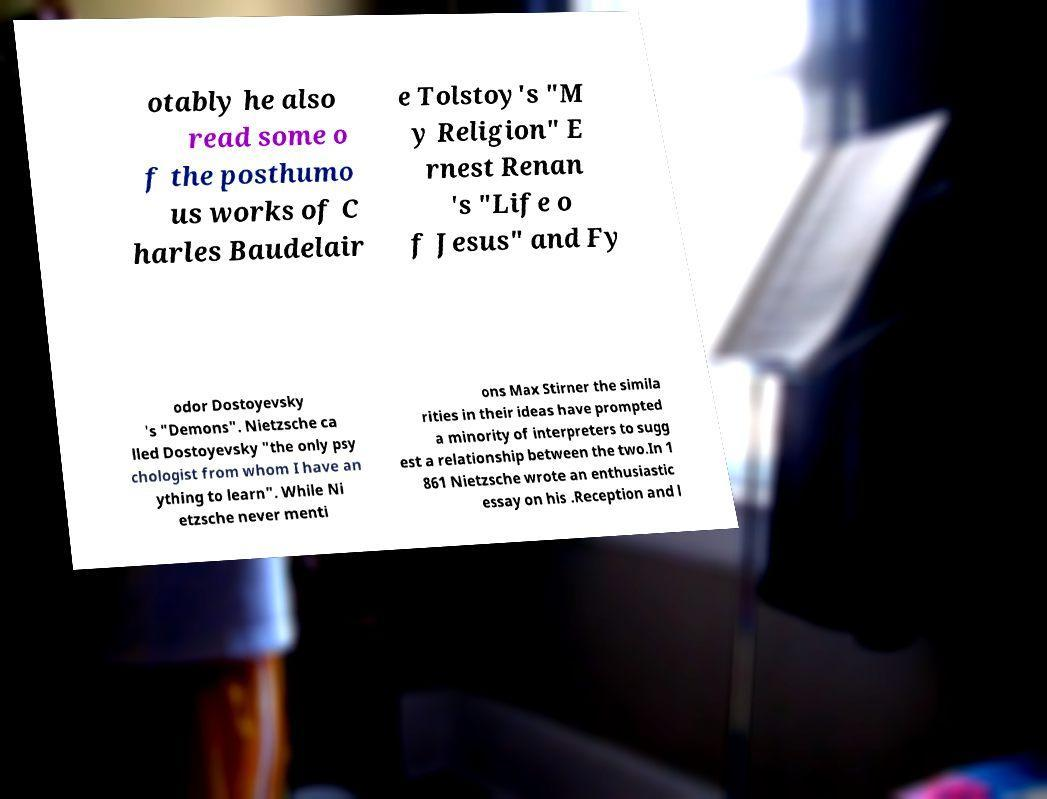There's text embedded in this image that I need extracted. Can you transcribe it verbatim? otably he also read some o f the posthumo us works of C harles Baudelair e Tolstoy's "M y Religion" E rnest Renan 's "Life o f Jesus" and Fy odor Dostoyevsky 's "Demons". Nietzsche ca lled Dostoyevsky "the only psy chologist from whom I have an ything to learn". While Ni etzsche never menti ons Max Stirner the simila rities in their ideas have prompted a minority of interpreters to sugg est a relationship between the two.In 1 861 Nietzsche wrote an enthusiastic essay on his .Reception and l 